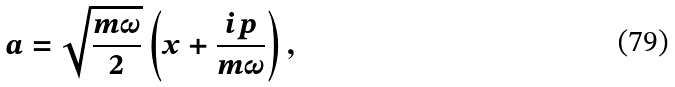Convert formula to latex. <formula><loc_0><loc_0><loc_500><loc_500>a = \sqrt { \frac { m \omega } { 2 } } \left ( x + \frac { i p } { m \omega } \right ) ,</formula> 